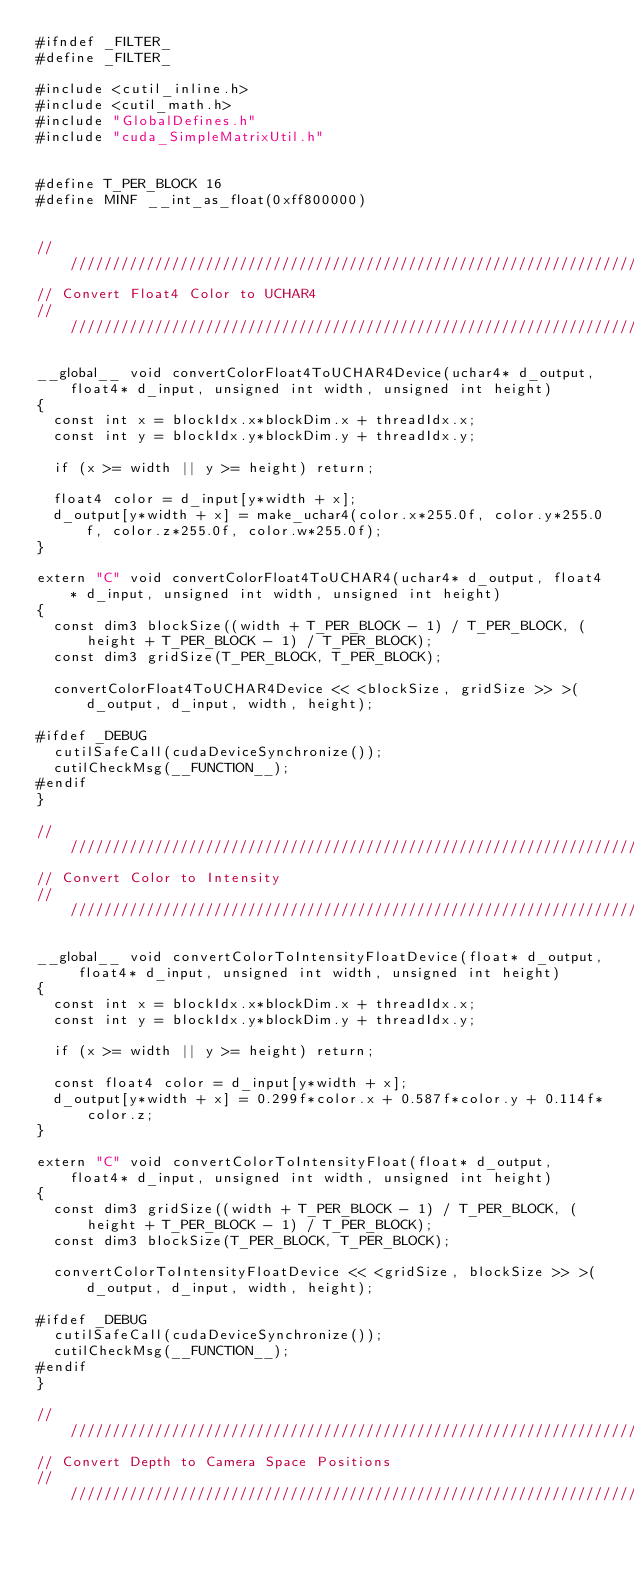Convert code to text. <code><loc_0><loc_0><loc_500><loc_500><_Cuda_>#ifndef _FILTER_
#define _FILTER_

#include <cutil_inline.h>
#include <cutil_math.h>
#include "GlobalDefines.h"
#include "cuda_SimpleMatrixUtil.h"


#define T_PER_BLOCK 16
#define MINF __int_as_float(0xff800000)


////////////////////////////////////////////////////////////////////////////////////////////////////////////////////////////////////////////////////////
// Convert Float4 Color to UCHAR4
////////////////////////////////////////////////////////////////////////////////////////////////////////////////////////////////////////////////////////

__global__ void convertColorFloat4ToUCHAR4Device(uchar4* d_output, float4* d_input, unsigned int width, unsigned int height)
{
	const int x = blockIdx.x*blockDim.x + threadIdx.x;
	const int y = blockIdx.y*blockDim.y + threadIdx.y;

	if (x >= width || y >= height) return;

	float4 color = d_input[y*width + x];
	d_output[y*width + x] = make_uchar4(color.x*255.0f, color.y*255.0f, color.z*255.0f, color.w*255.0f);
}

extern "C" void convertColorFloat4ToUCHAR4(uchar4* d_output, float4* d_input, unsigned int width, unsigned int height)
{
	const dim3 blockSize((width + T_PER_BLOCK - 1) / T_PER_BLOCK, (height + T_PER_BLOCK - 1) / T_PER_BLOCK);
	const dim3 gridSize(T_PER_BLOCK, T_PER_BLOCK);

	convertColorFloat4ToUCHAR4Device << <blockSize, gridSize >> >(d_output, d_input, width, height);

#ifdef _DEBUG
	cutilSafeCall(cudaDeviceSynchronize());
	cutilCheckMsg(__FUNCTION__);
#endif
}

////////////////////////////////////////////////////////////////////////////////////////////////////////////////////////////////////////////////////////
// Convert Color to Intensity
////////////////////////////////////////////////////////////////////////////////////////////////////////////////////////////////////////////////////////

__global__ void convertColorToIntensityFloatDevice(float* d_output, float4* d_input, unsigned int width, unsigned int height)
{
	const int x = blockIdx.x*blockDim.x + threadIdx.x;
	const int y = blockIdx.y*blockDim.y + threadIdx.y;

	if (x >= width || y >= height) return;

	const float4 color = d_input[y*width + x];
	d_output[y*width + x] = 0.299f*color.x + 0.587f*color.y + 0.114f*color.z;
}

extern "C" void convertColorToIntensityFloat(float* d_output, float4* d_input, unsigned int width, unsigned int height)
{
	const dim3 gridSize((width + T_PER_BLOCK - 1) / T_PER_BLOCK, (height + T_PER_BLOCK - 1) / T_PER_BLOCK);
	const dim3 blockSize(T_PER_BLOCK, T_PER_BLOCK);

	convertColorToIntensityFloatDevice << <gridSize, blockSize >> >(d_output, d_input, width, height);

#ifdef _DEBUG
	cutilSafeCall(cudaDeviceSynchronize());
	cutilCheckMsg(__FUNCTION__);
#endif
}

////////////////////////////////////////////////////////////////////////////////////////////////////////////////////////////////////////////////////////
// Convert Depth to Camera Space Positions
////////////////////////////////////////////////////////////////////////////////////////////////////////////////////////////////////////////////////////
</code> 